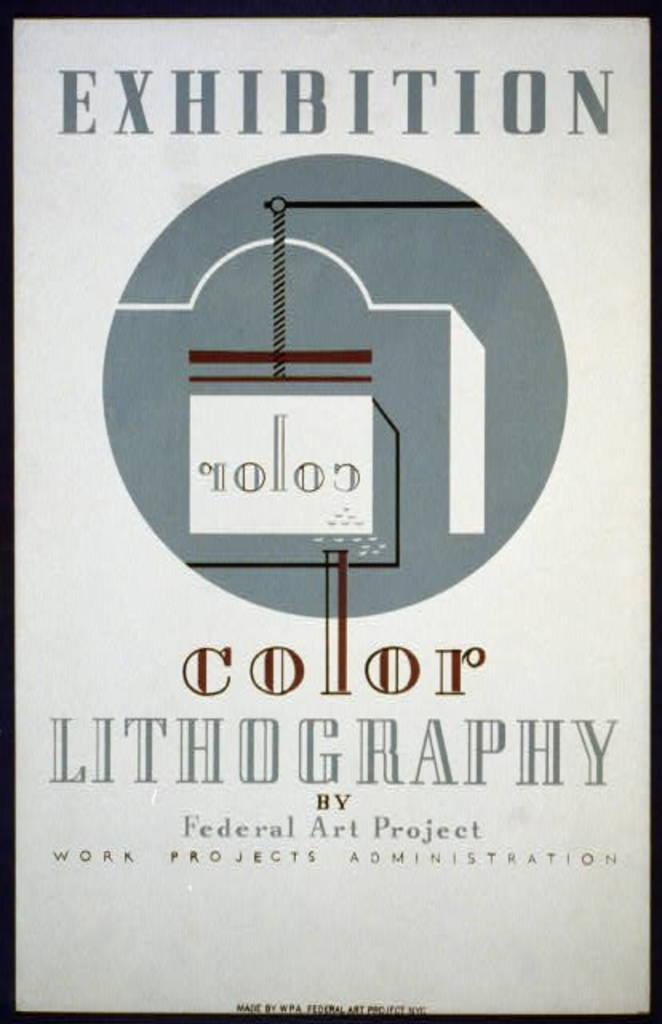<image>
Describe the image concisely. A sign advertises a color lithography exhibition by the FEderal Art PRoject. 